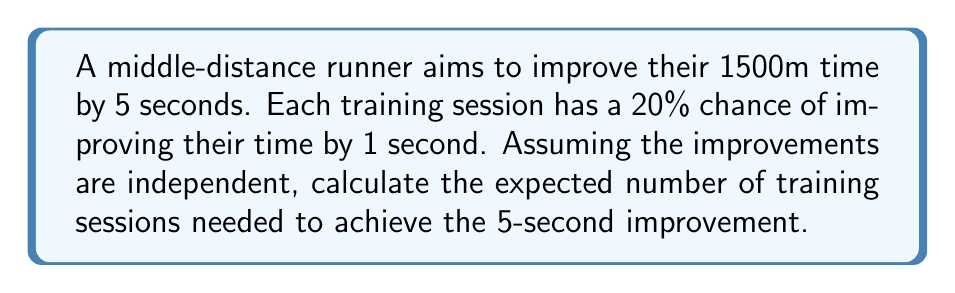Help me with this question. Let's approach this step-by-step:

1) This scenario follows a negative binomial distribution, where we're counting the number of trials (training sessions) needed to achieve a fixed number of successes (5 one-second improvements).

2) The probability of success (p) in each trial is 0.20 or 20%.

3) We need 5 successes (k) to achieve the 5-second improvement.

4) The expected number of trials in a negative binomial distribution is given by the formula:

   $$E(X) = \frac{k}{p}$$

   Where:
   - E(X) is the expected number of trials
   - k is the number of successes needed
   - p is the probability of success in each trial

5) Substituting our values:

   $$E(X) = \frac{5}{0.20} = 25$$

6) Therefore, the expected number of training sessions needed is 25.

Note: This model assumes that the probability of improvement remains constant and that improvements are independent, which may not always be the case in real-world training scenarios.
Answer: 25 training sessions 